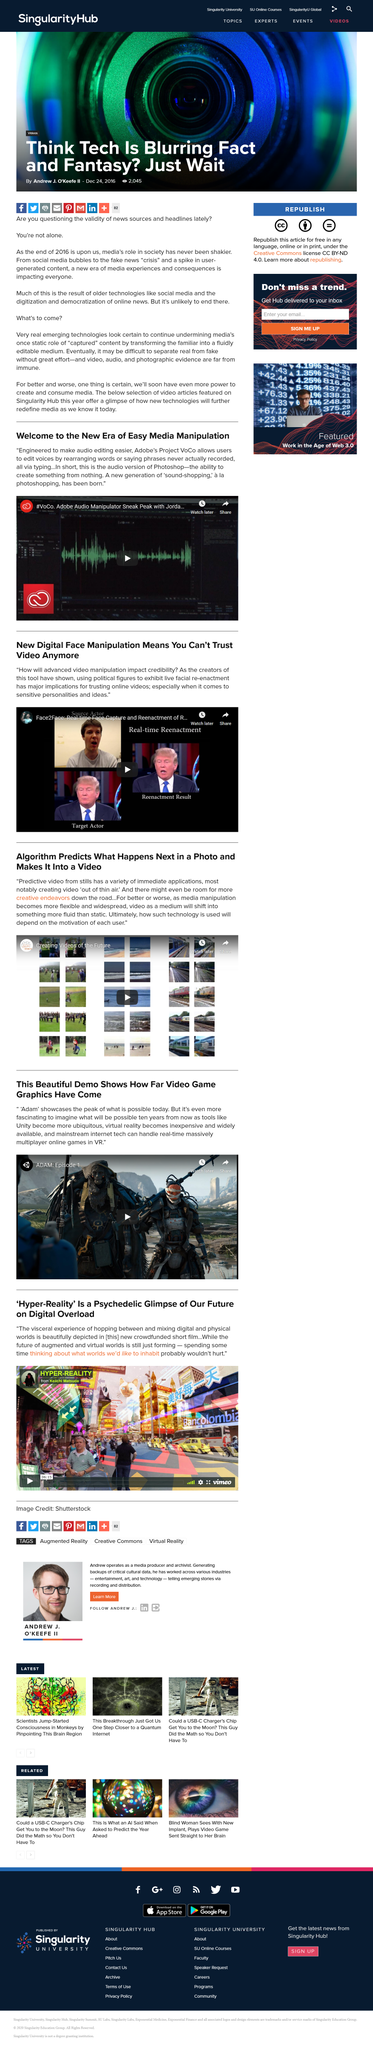Give some essential details in this illustration. Yes, it is possible to use political figures to exhibit live facial re-enactment. The title of the video is "ADAM: Episode 1" and it is shareable. Adobe is the company behind Project VoCo. Predictive video is an algorithm that analyzes a photo to predict what will happen next. Hyper-Reality was funded through the collective efforts of its supporters through crowd funding. 